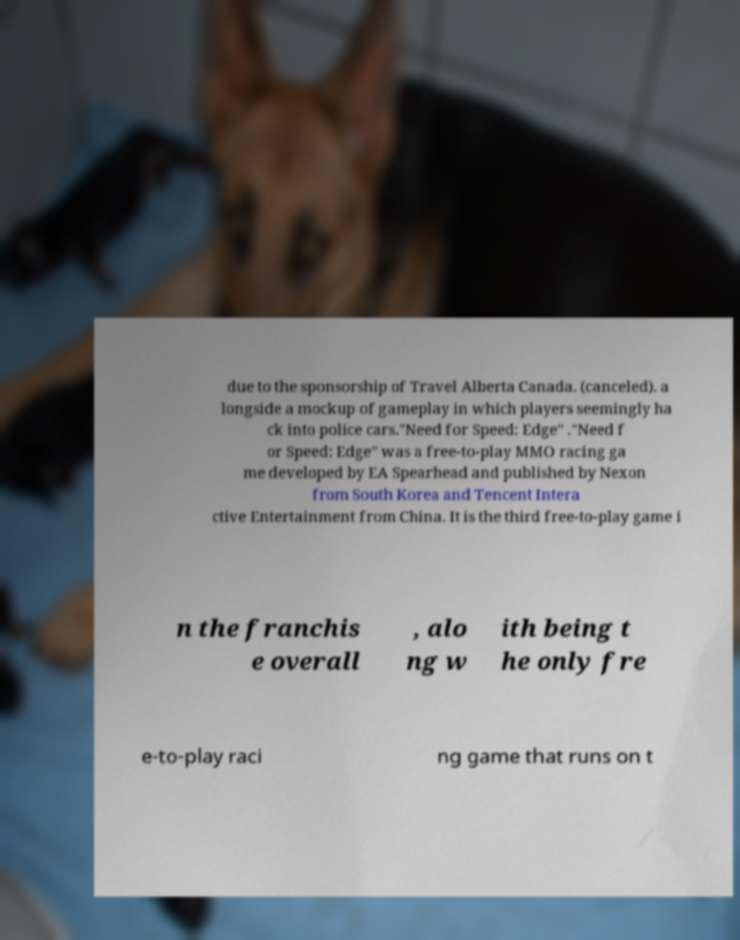What messages or text are displayed in this image? I need them in a readable, typed format. due to the sponsorship of Travel Alberta Canada. (canceled). a longside a mockup of gameplay in which players seemingly ha ck into police cars."Need for Speed: Edge" ."Need f or Speed: Edge" was a free-to-play MMO racing ga me developed by EA Spearhead and published by Nexon from South Korea and Tencent Intera ctive Entertainment from China. It is the third free-to-play game i n the franchis e overall , alo ng w ith being t he only fre e-to-play raci ng game that runs on t 